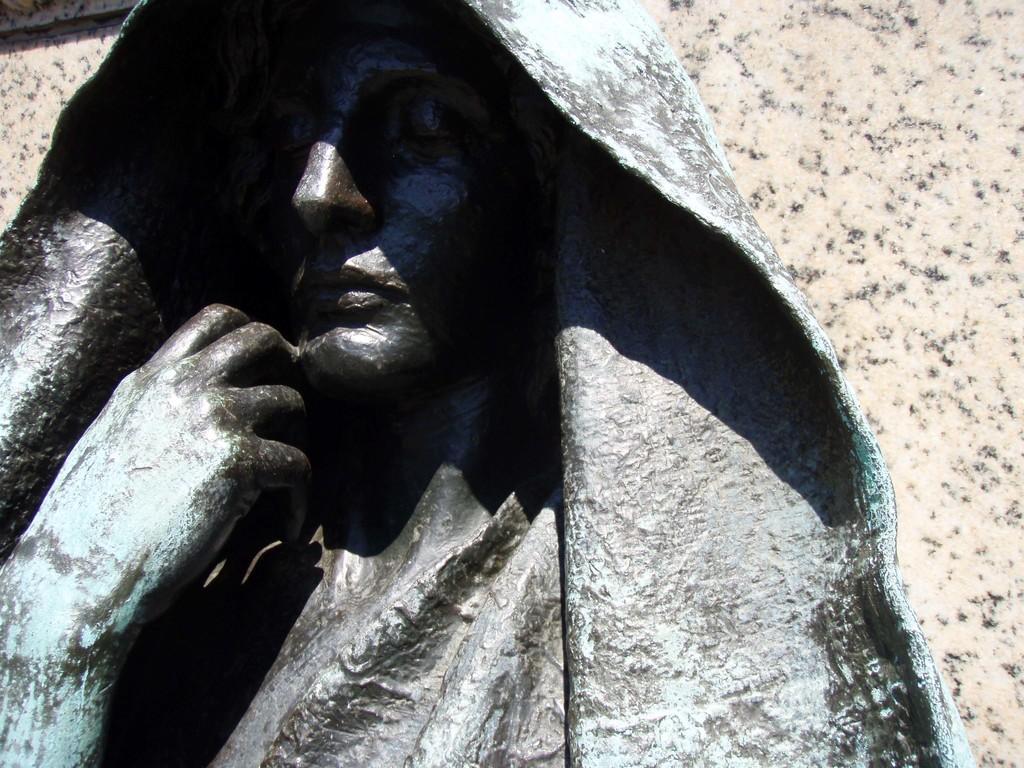Describe this image in one or two sentences. In this image we can see a sculpture. In the background there is a wall. 